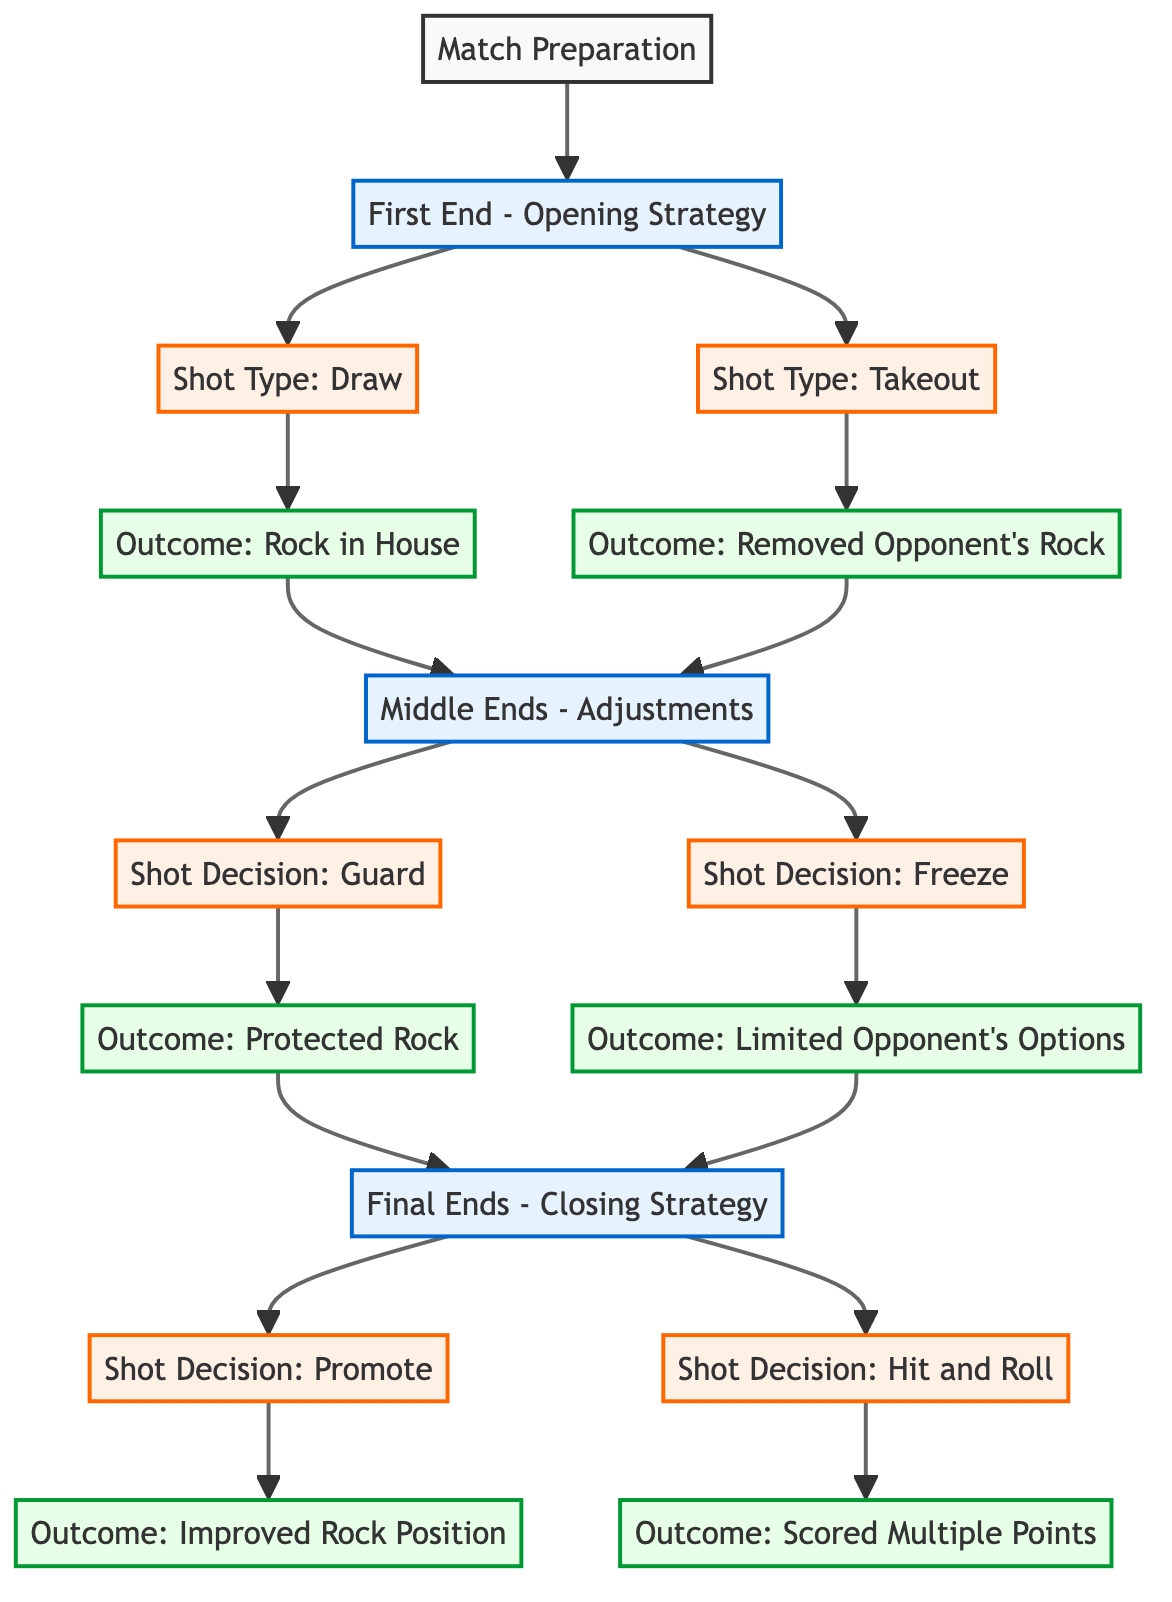What is the first step in the curling match strategy? The first step is "Match Preparation," which is represented as the initial node before any strategic decisions are made.
Answer: Match Preparation How many outcomes are listed for the Middle Ends? There are two outcomes listed for Middle Ends: "Protected Rock" and "Limited Opponent's Options." This can be derived from counting the nodes that branch from the "Middle Ends - Adjustments" node.
Answer: 2 What shot type is used in the Middle Ends for a guard? The shot type used in the Middle Ends for a guard is called "Guard." This is explicitly stated in the node that is connected to the "Middle Ends - Adjustments."
Answer: Guard What is the outcome of using the shot type "Freeze"? The outcome of using the shot type "Freeze" is "Limited Opponent's Options." This is shown directly in the outcome node connected to the "Freeze" shot decision.
Answer: Limited Opponent's Options What is the final strategy before ending the match? The final strategy before ending the match is "Final Ends - Closing Strategy." This is the last strategic decision point in the diagram before the final shot decisions are made.
Answer: Final Ends - Closing Strategy What are the final outcomes associated with the shot decisions in the last phase? The final outcomes are "Improved Rock Position" and "Scored Multiple Points," which come from the last two shot decision nodes in the "Final Ends - Closing Strategy."
Answer: Improved Rock Position, Scored Multiple Points Which shot decision results in scoring multiple points? The shot decision that results in scoring multiple points is "Hit and Roll." This is specified under the outcomes connected to the respective shot decision node in the final phase.
Answer: Hit and Roll What is the outcome of the "Draw" shot type? The outcome of the "Draw" shot type is "Rock in House." This can be found in the outcome node that is directly connected to the "Draw" shot type node in the first end.
Answer: Rock in House Which shot type is aimed at protecting a rock? The shot type aimed at protecting a rock is "Guard." This can be identified in the node associated with the shot decision for guarding in the Middle Ends.
Answer: Guard 